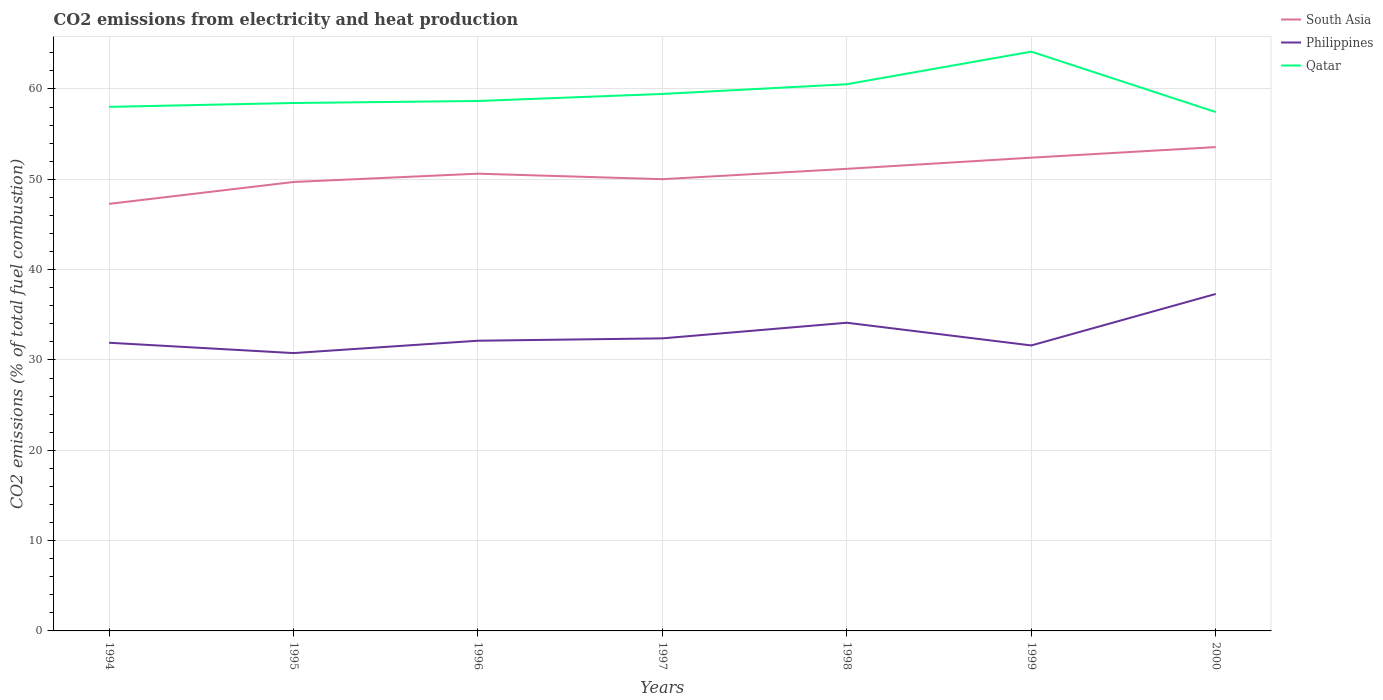Does the line corresponding to Qatar intersect with the line corresponding to South Asia?
Make the answer very short. No. Across all years, what is the maximum amount of CO2 emitted in Philippines?
Your answer should be very brief. 30.76. What is the total amount of CO2 emitted in South Asia in the graph?
Keep it short and to the point. -2.42. What is the difference between the highest and the second highest amount of CO2 emitted in Qatar?
Offer a terse response. 6.69. Is the amount of CO2 emitted in Philippines strictly greater than the amount of CO2 emitted in Qatar over the years?
Give a very brief answer. Yes. How many years are there in the graph?
Your answer should be very brief. 7. Does the graph contain any zero values?
Your response must be concise. No. Does the graph contain grids?
Your answer should be compact. Yes. Where does the legend appear in the graph?
Ensure brevity in your answer.  Top right. How are the legend labels stacked?
Offer a very short reply. Vertical. What is the title of the graph?
Ensure brevity in your answer.  CO2 emissions from electricity and heat production. What is the label or title of the Y-axis?
Give a very brief answer. CO2 emissions (% of total fuel combustion). What is the CO2 emissions (% of total fuel combustion) in South Asia in 1994?
Your answer should be compact. 47.28. What is the CO2 emissions (% of total fuel combustion) in Philippines in 1994?
Your answer should be very brief. 31.9. What is the CO2 emissions (% of total fuel combustion) of Qatar in 1994?
Your answer should be compact. 58.02. What is the CO2 emissions (% of total fuel combustion) of South Asia in 1995?
Provide a short and direct response. 49.7. What is the CO2 emissions (% of total fuel combustion) of Philippines in 1995?
Offer a terse response. 30.76. What is the CO2 emissions (% of total fuel combustion) of Qatar in 1995?
Your answer should be compact. 58.45. What is the CO2 emissions (% of total fuel combustion) of South Asia in 1996?
Provide a succinct answer. 50.62. What is the CO2 emissions (% of total fuel combustion) of Philippines in 1996?
Make the answer very short. 32.13. What is the CO2 emissions (% of total fuel combustion) in Qatar in 1996?
Provide a succinct answer. 58.67. What is the CO2 emissions (% of total fuel combustion) of South Asia in 1997?
Provide a succinct answer. 50.01. What is the CO2 emissions (% of total fuel combustion) in Philippines in 1997?
Keep it short and to the point. 32.39. What is the CO2 emissions (% of total fuel combustion) of Qatar in 1997?
Provide a succinct answer. 59.45. What is the CO2 emissions (% of total fuel combustion) of South Asia in 1998?
Ensure brevity in your answer.  51.16. What is the CO2 emissions (% of total fuel combustion) in Philippines in 1998?
Offer a terse response. 34.12. What is the CO2 emissions (% of total fuel combustion) of Qatar in 1998?
Your answer should be compact. 60.53. What is the CO2 emissions (% of total fuel combustion) in South Asia in 1999?
Give a very brief answer. 52.4. What is the CO2 emissions (% of total fuel combustion) of Philippines in 1999?
Provide a short and direct response. 31.61. What is the CO2 emissions (% of total fuel combustion) of Qatar in 1999?
Your answer should be compact. 64.13. What is the CO2 emissions (% of total fuel combustion) in South Asia in 2000?
Offer a terse response. 53.57. What is the CO2 emissions (% of total fuel combustion) of Philippines in 2000?
Your answer should be compact. 37.31. What is the CO2 emissions (% of total fuel combustion) in Qatar in 2000?
Give a very brief answer. 57.45. Across all years, what is the maximum CO2 emissions (% of total fuel combustion) of South Asia?
Your answer should be very brief. 53.57. Across all years, what is the maximum CO2 emissions (% of total fuel combustion) of Philippines?
Give a very brief answer. 37.31. Across all years, what is the maximum CO2 emissions (% of total fuel combustion) in Qatar?
Your response must be concise. 64.13. Across all years, what is the minimum CO2 emissions (% of total fuel combustion) in South Asia?
Give a very brief answer. 47.28. Across all years, what is the minimum CO2 emissions (% of total fuel combustion) of Philippines?
Keep it short and to the point. 30.76. Across all years, what is the minimum CO2 emissions (% of total fuel combustion) of Qatar?
Your answer should be compact. 57.45. What is the total CO2 emissions (% of total fuel combustion) of South Asia in the graph?
Offer a terse response. 354.74. What is the total CO2 emissions (% of total fuel combustion) of Philippines in the graph?
Your answer should be compact. 230.22. What is the total CO2 emissions (% of total fuel combustion) of Qatar in the graph?
Provide a succinct answer. 416.7. What is the difference between the CO2 emissions (% of total fuel combustion) in South Asia in 1994 and that in 1995?
Give a very brief answer. -2.42. What is the difference between the CO2 emissions (% of total fuel combustion) in Philippines in 1994 and that in 1995?
Offer a very short reply. 1.14. What is the difference between the CO2 emissions (% of total fuel combustion) of Qatar in 1994 and that in 1995?
Offer a terse response. -0.43. What is the difference between the CO2 emissions (% of total fuel combustion) of South Asia in 1994 and that in 1996?
Keep it short and to the point. -3.34. What is the difference between the CO2 emissions (% of total fuel combustion) of Philippines in 1994 and that in 1996?
Give a very brief answer. -0.23. What is the difference between the CO2 emissions (% of total fuel combustion) in Qatar in 1994 and that in 1996?
Your response must be concise. -0.65. What is the difference between the CO2 emissions (% of total fuel combustion) of South Asia in 1994 and that in 1997?
Offer a terse response. -2.73. What is the difference between the CO2 emissions (% of total fuel combustion) in Philippines in 1994 and that in 1997?
Ensure brevity in your answer.  -0.49. What is the difference between the CO2 emissions (% of total fuel combustion) in Qatar in 1994 and that in 1997?
Offer a very short reply. -1.43. What is the difference between the CO2 emissions (% of total fuel combustion) of South Asia in 1994 and that in 1998?
Ensure brevity in your answer.  -3.88. What is the difference between the CO2 emissions (% of total fuel combustion) in Philippines in 1994 and that in 1998?
Offer a terse response. -2.22. What is the difference between the CO2 emissions (% of total fuel combustion) in Qatar in 1994 and that in 1998?
Provide a succinct answer. -2.51. What is the difference between the CO2 emissions (% of total fuel combustion) of South Asia in 1994 and that in 1999?
Ensure brevity in your answer.  -5.11. What is the difference between the CO2 emissions (% of total fuel combustion) of Philippines in 1994 and that in 1999?
Keep it short and to the point. 0.3. What is the difference between the CO2 emissions (% of total fuel combustion) in Qatar in 1994 and that in 1999?
Keep it short and to the point. -6.11. What is the difference between the CO2 emissions (% of total fuel combustion) of South Asia in 1994 and that in 2000?
Provide a succinct answer. -6.29. What is the difference between the CO2 emissions (% of total fuel combustion) in Philippines in 1994 and that in 2000?
Provide a succinct answer. -5.4. What is the difference between the CO2 emissions (% of total fuel combustion) in Qatar in 1994 and that in 2000?
Give a very brief answer. 0.57. What is the difference between the CO2 emissions (% of total fuel combustion) in South Asia in 1995 and that in 1996?
Your answer should be very brief. -0.92. What is the difference between the CO2 emissions (% of total fuel combustion) in Philippines in 1995 and that in 1996?
Provide a succinct answer. -1.37. What is the difference between the CO2 emissions (% of total fuel combustion) of Qatar in 1995 and that in 1996?
Provide a short and direct response. -0.22. What is the difference between the CO2 emissions (% of total fuel combustion) of South Asia in 1995 and that in 1997?
Provide a succinct answer. -0.31. What is the difference between the CO2 emissions (% of total fuel combustion) of Philippines in 1995 and that in 1997?
Your answer should be very brief. -1.63. What is the difference between the CO2 emissions (% of total fuel combustion) in Qatar in 1995 and that in 1997?
Your answer should be very brief. -1. What is the difference between the CO2 emissions (% of total fuel combustion) of South Asia in 1995 and that in 1998?
Provide a succinct answer. -1.46. What is the difference between the CO2 emissions (% of total fuel combustion) in Philippines in 1995 and that in 1998?
Ensure brevity in your answer.  -3.36. What is the difference between the CO2 emissions (% of total fuel combustion) in Qatar in 1995 and that in 1998?
Provide a short and direct response. -2.08. What is the difference between the CO2 emissions (% of total fuel combustion) in South Asia in 1995 and that in 1999?
Keep it short and to the point. -2.69. What is the difference between the CO2 emissions (% of total fuel combustion) of Philippines in 1995 and that in 1999?
Offer a very short reply. -0.84. What is the difference between the CO2 emissions (% of total fuel combustion) of Qatar in 1995 and that in 1999?
Offer a terse response. -5.68. What is the difference between the CO2 emissions (% of total fuel combustion) of South Asia in 1995 and that in 2000?
Your answer should be very brief. -3.86. What is the difference between the CO2 emissions (% of total fuel combustion) in Philippines in 1995 and that in 2000?
Offer a very short reply. -6.55. What is the difference between the CO2 emissions (% of total fuel combustion) of Qatar in 1995 and that in 2000?
Give a very brief answer. 1. What is the difference between the CO2 emissions (% of total fuel combustion) of South Asia in 1996 and that in 1997?
Keep it short and to the point. 0.61. What is the difference between the CO2 emissions (% of total fuel combustion) of Philippines in 1996 and that in 1997?
Your answer should be compact. -0.26. What is the difference between the CO2 emissions (% of total fuel combustion) of Qatar in 1996 and that in 1997?
Offer a very short reply. -0.78. What is the difference between the CO2 emissions (% of total fuel combustion) of South Asia in 1996 and that in 1998?
Offer a very short reply. -0.54. What is the difference between the CO2 emissions (% of total fuel combustion) in Philippines in 1996 and that in 1998?
Make the answer very short. -1.99. What is the difference between the CO2 emissions (% of total fuel combustion) in Qatar in 1996 and that in 1998?
Ensure brevity in your answer.  -1.86. What is the difference between the CO2 emissions (% of total fuel combustion) in South Asia in 1996 and that in 1999?
Give a very brief answer. -1.77. What is the difference between the CO2 emissions (% of total fuel combustion) in Philippines in 1996 and that in 1999?
Offer a very short reply. 0.52. What is the difference between the CO2 emissions (% of total fuel combustion) of Qatar in 1996 and that in 1999?
Offer a terse response. -5.46. What is the difference between the CO2 emissions (% of total fuel combustion) in South Asia in 1996 and that in 2000?
Offer a terse response. -2.94. What is the difference between the CO2 emissions (% of total fuel combustion) in Philippines in 1996 and that in 2000?
Your answer should be compact. -5.18. What is the difference between the CO2 emissions (% of total fuel combustion) in Qatar in 1996 and that in 2000?
Offer a terse response. 1.22. What is the difference between the CO2 emissions (% of total fuel combustion) of South Asia in 1997 and that in 1998?
Keep it short and to the point. -1.15. What is the difference between the CO2 emissions (% of total fuel combustion) in Philippines in 1997 and that in 1998?
Provide a short and direct response. -1.73. What is the difference between the CO2 emissions (% of total fuel combustion) in Qatar in 1997 and that in 1998?
Your answer should be very brief. -1.08. What is the difference between the CO2 emissions (% of total fuel combustion) of South Asia in 1997 and that in 1999?
Your answer should be compact. -2.38. What is the difference between the CO2 emissions (% of total fuel combustion) of Philippines in 1997 and that in 1999?
Offer a terse response. 0.79. What is the difference between the CO2 emissions (% of total fuel combustion) in Qatar in 1997 and that in 1999?
Offer a terse response. -4.68. What is the difference between the CO2 emissions (% of total fuel combustion) in South Asia in 1997 and that in 2000?
Your answer should be very brief. -3.55. What is the difference between the CO2 emissions (% of total fuel combustion) in Philippines in 1997 and that in 2000?
Provide a succinct answer. -4.92. What is the difference between the CO2 emissions (% of total fuel combustion) of Qatar in 1997 and that in 2000?
Your answer should be compact. 2. What is the difference between the CO2 emissions (% of total fuel combustion) of South Asia in 1998 and that in 1999?
Keep it short and to the point. -1.24. What is the difference between the CO2 emissions (% of total fuel combustion) in Philippines in 1998 and that in 1999?
Your answer should be very brief. 2.51. What is the difference between the CO2 emissions (% of total fuel combustion) in Qatar in 1998 and that in 1999?
Keep it short and to the point. -3.61. What is the difference between the CO2 emissions (% of total fuel combustion) of South Asia in 1998 and that in 2000?
Keep it short and to the point. -2.41. What is the difference between the CO2 emissions (% of total fuel combustion) of Philippines in 1998 and that in 2000?
Make the answer very short. -3.19. What is the difference between the CO2 emissions (% of total fuel combustion) of Qatar in 1998 and that in 2000?
Offer a very short reply. 3.08. What is the difference between the CO2 emissions (% of total fuel combustion) in South Asia in 1999 and that in 2000?
Provide a short and direct response. -1.17. What is the difference between the CO2 emissions (% of total fuel combustion) in Philippines in 1999 and that in 2000?
Ensure brevity in your answer.  -5.7. What is the difference between the CO2 emissions (% of total fuel combustion) of Qatar in 1999 and that in 2000?
Provide a succinct answer. 6.69. What is the difference between the CO2 emissions (% of total fuel combustion) in South Asia in 1994 and the CO2 emissions (% of total fuel combustion) in Philippines in 1995?
Your answer should be very brief. 16.52. What is the difference between the CO2 emissions (% of total fuel combustion) in South Asia in 1994 and the CO2 emissions (% of total fuel combustion) in Qatar in 1995?
Your response must be concise. -11.17. What is the difference between the CO2 emissions (% of total fuel combustion) of Philippines in 1994 and the CO2 emissions (% of total fuel combustion) of Qatar in 1995?
Give a very brief answer. -26.54. What is the difference between the CO2 emissions (% of total fuel combustion) in South Asia in 1994 and the CO2 emissions (% of total fuel combustion) in Philippines in 1996?
Offer a terse response. 15.15. What is the difference between the CO2 emissions (% of total fuel combustion) of South Asia in 1994 and the CO2 emissions (% of total fuel combustion) of Qatar in 1996?
Ensure brevity in your answer.  -11.39. What is the difference between the CO2 emissions (% of total fuel combustion) of Philippines in 1994 and the CO2 emissions (% of total fuel combustion) of Qatar in 1996?
Offer a very short reply. -26.77. What is the difference between the CO2 emissions (% of total fuel combustion) in South Asia in 1994 and the CO2 emissions (% of total fuel combustion) in Philippines in 1997?
Offer a terse response. 14.89. What is the difference between the CO2 emissions (% of total fuel combustion) in South Asia in 1994 and the CO2 emissions (% of total fuel combustion) in Qatar in 1997?
Ensure brevity in your answer.  -12.17. What is the difference between the CO2 emissions (% of total fuel combustion) of Philippines in 1994 and the CO2 emissions (% of total fuel combustion) of Qatar in 1997?
Offer a very short reply. -27.55. What is the difference between the CO2 emissions (% of total fuel combustion) in South Asia in 1994 and the CO2 emissions (% of total fuel combustion) in Philippines in 1998?
Make the answer very short. 13.16. What is the difference between the CO2 emissions (% of total fuel combustion) of South Asia in 1994 and the CO2 emissions (% of total fuel combustion) of Qatar in 1998?
Offer a terse response. -13.25. What is the difference between the CO2 emissions (% of total fuel combustion) of Philippines in 1994 and the CO2 emissions (% of total fuel combustion) of Qatar in 1998?
Provide a short and direct response. -28.62. What is the difference between the CO2 emissions (% of total fuel combustion) in South Asia in 1994 and the CO2 emissions (% of total fuel combustion) in Philippines in 1999?
Give a very brief answer. 15.67. What is the difference between the CO2 emissions (% of total fuel combustion) of South Asia in 1994 and the CO2 emissions (% of total fuel combustion) of Qatar in 1999?
Your response must be concise. -16.85. What is the difference between the CO2 emissions (% of total fuel combustion) of Philippines in 1994 and the CO2 emissions (% of total fuel combustion) of Qatar in 1999?
Offer a terse response. -32.23. What is the difference between the CO2 emissions (% of total fuel combustion) in South Asia in 1994 and the CO2 emissions (% of total fuel combustion) in Philippines in 2000?
Provide a short and direct response. 9.97. What is the difference between the CO2 emissions (% of total fuel combustion) of South Asia in 1994 and the CO2 emissions (% of total fuel combustion) of Qatar in 2000?
Offer a terse response. -10.17. What is the difference between the CO2 emissions (% of total fuel combustion) in Philippines in 1994 and the CO2 emissions (% of total fuel combustion) in Qatar in 2000?
Ensure brevity in your answer.  -25.54. What is the difference between the CO2 emissions (% of total fuel combustion) of South Asia in 1995 and the CO2 emissions (% of total fuel combustion) of Philippines in 1996?
Your answer should be compact. 17.57. What is the difference between the CO2 emissions (% of total fuel combustion) in South Asia in 1995 and the CO2 emissions (% of total fuel combustion) in Qatar in 1996?
Offer a very short reply. -8.97. What is the difference between the CO2 emissions (% of total fuel combustion) in Philippines in 1995 and the CO2 emissions (% of total fuel combustion) in Qatar in 1996?
Make the answer very short. -27.91. What is the difference between the CO2 emissions (% of total fuel combustion) in South Asia in 1995 and the CO2 emissions (% of total fuel combustion) in Philippines in 1997?
Offer a terse response. 17.31. What is the difference between the CO2 emissions (% of total fuel combustion) in South Asia in 1995 and the CO2 emissions (% of total fuel combustion) in Qatar in 1997?
Provide a short and direct response. -9.75. What is the difference between the CO2 emissions (% of total fuel combustion) in Philippines in 1995 and the CO2 emissions (% of total fuel combustion) in Qatar in 1997?
Provide a short and direct response. -28.69. What is the difference between the CO2 emissions (% of total fuel combustion) in South Asia in 1995 and the CO2 emissions (% of total fuel combustion) in Philippines in 1998?
Keep it short and to the point. 15.58. What is the difference between the CO2 emissions (% of total fuel combustion) of South Asia in 1995 and the CO2 emissions (% of total fuel combustion) of Qatar in 1998?
Keep it short and to the point. -10.82. What is the difference between the CO2 emissions (% of total fuel combustion) of Philippines in 1995 and the CO2 emissions (% of total fuel combustion) of Qatar in 1998?
Offer a very short reply. -29.77. What is the difference between the CO2 emissions (% of total fuel combustion) of South Asia in 1995 and the CO2 emissions (% of total fuel combustion) of Philippines in 1999?
Your response must be concise. 18.1. What is the difference between the CO2 emissions (% of total fuel combustion) of South Asia in 1995 and the CO2 emissions (% of total fuel combustion) of Qatar in 1999?
Offer a very short reply. -14.43. What is the difference between the CO2 emissions (% of total fuel combustion) of Philippines in 1995 and the CO2 emissions (% of total fuel combustion) of Qatar in 1999?
Offer a terse response. -33.37. What is the difference between the CO2 emissions (% of total fuel combustion) of South Asia in 1995 and the CO2 emissions (% of total fuel combustion) of Philippines in 2000?
Offer a very short reply. 12.4. What is the difference between the CO2 emissions (% of total fuel combustion) of South Asia in 1995 and the CO2 emissions (% of total fuel combustion) of Qatar in 2000?
Keep it short and to the point. -7.74. What is the difference between the CO2 emissions (% of total fuel combustion) in Philippines in 1995 and the CO2 emissions (% of total fuel combustion) in Qatar in 2000?
Give a very brief answer. -26.69. What is the difference between the CO2 emissions (% of total fuel combustion) of South Asia in 1996 and the CO2 emissions (% of total fuel combustion) of Philippines in 1997?
Keep it short and to the point. 18.23. What is the difference between the CO2 emissions (% of total fuel combustion) in South Asia in 1996 and the CO2 emissions (% of total fuel combustion) in Qatar in 1997?
Your answer should be compact. -8.83. What is the difference between the CO2 emissions (% of total fuel combustion) of Philippines in 1996 and the CO2 emissions (% of total fuel combustion) of Qatar in 1997?
Give a very brief answer. -27.32. What is the difference between the CO2 emissions (% of total fuel combustion) of South Asia in 1996 and the CO2 emissions (% of total fuel combustion) of Philippines in 1998?
Make the answer very short. 16.5. What is the difference between the CO2 emissions (% of total fuel combustion) of South Asia in 1996 and the CO2 emissions (% of total fuel combustion) of Qatar in 1998?
Your answer should be very brief. -9.9. What is the difference between the CO2 emissions (% of total fuel combustion) in Philippines in 1996 and the CO2 emissions (% of total fuel combustion) in Qatar in 1998?
Ensure brevity in your answer.  -28.4. What is the difference between the CO2 emissions (% of total fuel combustion) in South Asia in 1996 and the CO2 emissions (% of total fuel combustion) in Philippines in 1999?
Offer a very short reply. 19.02. What is the difference between the CO2 emissions (% of total fuel combustion) of South Asia in 1996 and the CO2 emissions (% of total fuel combustion) of Qatar in 1999?
Offer a very short reply. -13.51. What is the difference between the CO2 emissions (% of total fuel combustion) in Philippines in 1996 and the CO2 emissions (% of total fuel combustion) in Qatar in 1999?
Offer a terse response. -32. What is the difference between the CO2 emissions (% of total fuel combustion) of South Asia in 1996 and the CO2 emissions (% of total fuel combustion) of Philippines in 2000?
Offer a very short reply. 13.32. What is the difference between the CO2 emissions (% of total fuel combustion) in South Asia in 1996 and the CO2 emissions (% of total fuel combustion) in Qatar in 2000?
Provide a short and direct response. -6.82. What is the difference between the CO2 emissions (% of total fuel combustion) in Philippines in 1996 and the CO2 emissions (% of total fuel combustion) in Qatar in 2000?
Your answer should be compact. -25.32. What is the difference between the CO2 emissions (% of total fuel combustion) of South Asia in 1997 and the CO2 emissions (% of total fuel combustion) of Philippines in 1998?
Keep it short and to the point. 15.89. What is the difference between the CO2 emissions (% of total fuel combustion) in South Asia in 1997 and the CO2 emissions (% of total fuel combustion) in Qatar in 1998?
Keep it short and to the point. -10.51. What is the difference between the CO2 emissions (% of total fuel combustion) of Philippines in 1997 and the CO2 emissions (% of total fuel combustion) of Qatar in 1998?
Keep it short and to the point. -28.14. What is the difference between the CO2 emissions (% of total fuel combustion) in South Asia in 1997 and the CO2 emissions (% of total fuel combustion) in Philippines in 1999?
Ensure brevity in your answer.  18.41. What is the difference between the CO2 emissions (% of total fuel combustion) in South Asia in 1997 and the CO2 emissions (% of total fuel combustion) in Qatar in 1999?
Your response must be concise. -14.12. What is the difference between the CO2 emissions (% of total fuel combustion) in Philippines in 1997 and the CO2 emissions (% of total fuel combustion) in Qatar in 1999?
Provide a succinct answer. -31.74. What is the difference between the CO2 emissions (% of total fuel combustion) of South Asia in 1997 and the CO2 emissions (% of total fuel combustion) of Philippines in 2000?
Offer a terse response. 12.71. What is the difference between the CO2 emissions (% of total fuel combustion) of South Asia in 1997 and the CO2 emissions (% of total fuel combustion) of Qatar in 2000?
Your answer should be very brief. -7.43. What is the difference between the CO2 emissions (% of total fuel combustion) of Philippines in 1997 and the CO2 emissions (% of total fuel combustion) of Qatar in 2000?
Your response must be concise. -25.06. What is the difference between the CO2 emissions (% of total fuel combustion) in South Asia in 1998 and the CO2 emissions (% of total fuel combustion) in Philippines in 1999?
Make the answer very short. 19.55. What is the difference between the CO2 emissions (% of total fuel combustion) in South Asia in 1998 and the CO2 emissions (% of total fuel combustion) in Qatar in 1999?
Your answer should be compact. -12.97. What is the difference between the CO2 emissions (% of total fuel combustion) of Philippines in 1998 and the CO2 emissions (% of total fuel combustion) of Qatar in 1999?
Provide a succinct answer. -30.01. What is the difference between the CO2 emissions (% of total fuel combustion) in South Asia in 1998 and the CO2 emissions (% of total fuel combustion) in Philippines in 2000?
Offer a terse response. 13.85. What is the difference between the CO2 emissions (% of total fuel combustion) in South Asia in 1998 and the CO2 emissions (% of total fuel combustion) in Qatar in 2000?
Keep it short and to the point. -6.29. What is the difference between the CO2 emissions (% of total fuel combustion) in Philippines in 1998 and the CO2 emissions (% of total fuel combustion) in Qatar in 2000?
Provide a succinct answer. -23.33. What is the difference between the CO2 emissions (% of total fuel combustion) in South Asia in 1999 and the CO2 emissions (% of total fuel combustion) in Philippines in 2000?
Provide a succinct answer. 15.09. What is the difference between the CO2 emissions (% of total fuel combustion) of South Asia in 1999 and the CO2 emissions (% of total fuel combustion) of Qatar in 2000?
Provide a succinct answer. -5.05. What is the difference between the CO2 emissions (% of total fuel combustion) of Philippines in 1999 and the CO2 emissions (% of total fuel combustion) of Qatar in 2000?
Your response must be concise. -25.84. What is the average CO2 emissions (% of total fuel combustion) in South Asia per year?
Provide a succinct answer. 50.68. What is the average CO2 emissions (% of total fuel combustion) in Philippines per year?
Provide a succinct answer. 32.89. What is the average CO2 emissions (% of total fuel combustion) of Qatar per year?
Make the answer very short. 59.53. In the year 1994, what is the difference between the CO2 emissions (% of total fuel combustion) in South Asia and CO2 emissions (% of total fuel combustion) in Philippines?
Ensure brevity in your answer.  15.38. In the year 1994, what is the difference between the CO2 emissions (% of total fuel combustion) in South Asia and CO2 emissions (% of total fuel combustion) in Qatar?
Give a very brief answer. -10.74. In the year 1994, what is the difference between the CO2 emissions (% of total fuel combustion) of Philippines and CO2 emissions (% of total fuel combustion) of Qatar?
Your answer should be very brief. -26.12. In the year 1995, what is the difference between the CO2 emissions (% of total fuel combustion) in South Asia and CO2 emissions (% of total fuel combustion) in Philippines?
Provide a succinct answer. 18.94. In the year 1995, what is the difference between the CO2 emissions (% of total fuel combustion) of South Asia and CO2 emissions (% of total fuel combustion) of Qatar?
Offer a terse response. -8.75. In the year 1995, what is the difference between the CO2 emissions (% of total fuel combustion) in Philippines and CO2 emissions (% of total fuel combustion) in Qatar?
Offer a terse response. -27.69. In the year 1996, what is the difference between the CO2 emissions (% of total fuel combustion) of South Asia and CO2 emissions (% of total fuel combustion) of Philippines?
Your answer should be very brief. 18.49. In the year 1996, what is the difference between the CO2 emissions (% of total fuel combustion) of South Asia and CO2 emissions (% of total fuel combustion) of Qatar?
Keep it short and to the point. -8.05. In the year 1996, what is the difference between the CO2 emissions (% of total fuel combustion) of Philippines and CO2 emissions (% of total fuel combustion) of Qatar?
Your answer should be compact. -26.54. In the year 1997, what is the difference between the CO2 emissions (% of total fuel combustion) in South Asia and CO2 emissions (% of total fuel combustion) in Philippines?
Keep it short and to the point. 17.62. In the year 1997, what is the difference between the CO2 emissions (% of total fuel combustion) of South Asia and CO2 emissions (% of total fuel combustion) of Qatar?
Provide a short and direct response. -9.44. In the year 1997, what is the difference between the CO2 emissions (% of total fuel combustion) in Philippines and CO2 emissions (% of total fuel combustion) in Qatar?
Make the answer very short. -27.06. In the year 1998, what is the difference between the CO2 emissions (% of total fuel combustion) of South Asia and CO2 emissions (% of total fuel combustion) of Philippines?
Offer a very short reply. 17.04. In the year 1998, what is the difference between the CO2 emissions (% of total fuel combustion) of South Asia and CO2 emissions (% of total fuel combustion) of Qatar?
Provide a short and direct response. -9.37. In the year 1998, what is the difference between the CO2 emissions (% of total fuel combustion) in Philippines and CO2 emissions (% of total fuel combustion) in Qatar?
Keep it short and to the point. -26.41. In the year 1999, what is the difference between the CO2 emissions (% of total fuel combustion) in South Asia and CO2 emissions (% of total fuel combustion) in Philippines?
Give a very brief answer. 20.79. In the year 1999, what is the difference between the CO2 emissions (% of total fuel combustion) of South Asia and CO2 emissions (% of total fuel combustion) of Qatar?
Keep it short and to the point. -11.74. In the year 1999, what is the difference between the CO2 emissions (% of total fuel combustion) of Philippines and CO2 emissions (% of total fuel combustion) of Qatar?
Offer a very short reply. -32.53. In the year 2000, what is the difference between the CO2 emissions (% of total fuel combustion) in South Asia and CO2 emissions (% of total fuel combustion) in Philippines?
Offer a terse response. 16.26. In the year 2000, what is the difference between the CO2 emissions (% of total fuel combustion) in South Asia and CO2 emissions (% of total fuel combustion) in Qatar?
Your answer should be compact. -3.88. In the year 2000, what is the difference between the CO2 emissions (% of total fuel combustion) of Philippines and CO2 emissions (% of total fuel combustion) of Qatar?
Give a very brief answer. -20.14. What is the ratio of the CO2 emissions (% of total fuel combustion) of South Asia in 1994 to that in 1995?
Give a very brief answer. 0.95. What is the ratio of the CO2 emissions (% of total fuel combustion) of Philippines in 1994 to that in 1995?
Offer a very short reply. 1.04. What is the ratio of the CO2 emissions (% of total fuel combustion) of Qatar in 1994 to that in 1995?
Ensure brevity in your answer.  0.99. What is the ratio of the CO2 emissions (% of total fuel combustion) in South Asia in 1994 to that in 1996?
Keep it short and to the point. 0.93. What is the ratio of the CO2 emissions (% of total fuel combustion) of Qatar in 1994 to that in 1996?
Make the answer very short. 0.99. What is the ratio of the CO2 emissions (% of total fuel combustion) of South Asia in 1994 to that in 1997?
Your answer should be very brief. 0.95. What is the ratio of the CO2 emissions (% of total fuel combustion) in South Asia in 1994 to that in 1998?
Your answer should be compact. 0.92. What is the ratio of the CO2 emissions (% of total fuel combustion) in Philippines in 1994 to that in 1998?
Provide a succinct answer. 0.94. What is the ratio of the CO2 emissions (% of total fuel combustion) in Qatar in 1994 to that in 1998?
Your answer should be very brief. 0.96. What is the ratio of the CO2 emissions (% of total fuel combustion) of South Asia in 1994 to that in 1999?
Give a very brief answer. 0.9. What is the ratio of the CO2 emissions (% of total fuel combustion) in Philippines in 1994 to that in 1999?
Your answer should be very brief. 1.01. What is the ratio of the CO2 emissions (% of total fuel combustion) of Qatar in 1994 to that in 1999?
Make the answer very short. 0.9. What is the ratio of the CO2 emissions (% of total fuel combustion) in South Asia in 1994 to that in 2000?
Make the answer very short. 0.88. What is the ratio of the CO2 emissions (% of total fuel combustion) of Philippines in 1994 to that in 2000?
Provide a short and direct response. 0.86. What is the ratio of the CO2 emissions (% of total fuel combustion) in Qatar in 1994 to that in 2000?
Give a very brief answer. 1.01. What is the ratio of the CO2 emissions (% of total fuel combustion) in South Asia in 1995 to that in 1996?
Offer a terse response. 0.98. What is the ratio of the CO2 emissions (% of total fuel combustion) in Philippines in 1995 to that in 1996?
Your answer should be compact. 0.96. What is the ratio of the CO2 emissions (% of total fuel combustion) of South Asia in 1995 to that in 1997?
Give a very brief answer. 0.99. What is the ratio of the CO2 emissions (% of total fuel combustion) of Philippines in 1995 to that in 1997?
Provide a succinct answer. 0.95. What is the ratio of the CO2 emissions (% of total fuel combustion) in Qatar in 1995 to that in 1997?
Provide a succinct answer. 0.98. What is the ratio of the CO2 emissions (% of total fuel combustion) in South Asia in 1995 to that in 1998?
Your response must be concise. 0.97. What is the ratio of the CO2 emissions (% of total fuel combustion) of Philippines in 1995 to that in 1998?
Your response must be concise. 0.9. What is the ratio of the CO2 emissions (% of total fuel combustion) in Qatar in 1995 to that in 1998?
Give a very brief answer. 0.97. What is the ratio of the CO2 emissions (% of total fuel combustion) in South Asia in 1995 to that in 1999?
Make the answer very short. 0.95. What is the ratio of the CO2 emissions (% of total fuel combustion) in Philippines in 1995 to that in 1999?
Offer a very short reply. 0.97. What is the ratio of the CO2 emissions (% of total fuel combustion) in Qatar in 1995 to that in 1999?
Your response must be concise. 0.91. What is the ratio of the CO2 emissions (% of total fuel combustion) of South Asia in 1995 to that in 2000?
Provide a succinct answer. 0.93. What is the ratio of the CO2 emissions (% of total fuel combustion) of Philippines in 1995 to that in 2000?
Your answer should be very brief. 0.82. What is the ratio of the CO2 emissions (% of total fuel combustion) of Qatar in 1995 to that in 2000?
Your answer should be very brief. 1.02. What is the ratio of the CO2 emissions (% of total fuel combustion) in South Asia in 1996 to that in 1997?
Make the answer very short. 1.01. What is the ratio of the CO2 emissions (% of total fuel combustion) in Philippines in 1996 to that in 1997?
Your response must be concise. 0.99. What is the ratio of the CO2 emissions (% of total fuel combustion) of Qatar in 1996 to that in 1997?
Provide a succinct answer. 0.99. What is the ratio of the CO2 emissions (% of total fuel combustion) in South Asia in 1996 to that in 1998?
Ensure brevity in your answer.  0.99. What is the ratio of the CO2 emissions (% of total fuel combustion) of Philippines in 1996 to that in 1998?
Your response must be concise. 0.94. What is the ratio of the CO2 emissions (% of total fuel combustion) in Qatar in 1996 to that in 1998?
Give a very brief answer. 0.97. What is the ratio of the CO2 emissions (% of total fuel combustion) in South Asia in 1996 to that in 1999?
Provide a short and direct response. 0.97. What is the ratio of the CO2 emissions (% of total fuel combustion) of Philippines in 1996 to that in 1999?
Offer a very short reply. 1.02. What is the ratio of the CO2 emissions (% of total fuel combustion) of Qatar in 1996 to that in 1999?
Make the answer very short. 0.91. What is the ratio of the CO2 emissions (% of total fuel combustion) in South Asia in 1996 to that in 2000?
Provide a succinct answer. 0.95. What is the ratio of the CO2 emissions (% of total fuel combustion) of Philippines in 1996 to that in 2000?
Your answer should be very brief. 0.86. What is the ratio of the CO2 emissions (% of total fuel combustion) in Qatar in 1996 to that in 2000?
Give a very brief answer. 1.02. What is the ratio of the CO2 emissions (% of total fuel combustion) in South Asia in 1997 to that in 1998?
Give a very brief answer. 0.98. What is the ratio of the CO2 emissions (% of total fuel combustion) of Philippines in 1997 to that in 1998?
Your answer should be compact. 0.95. What is the ratio of the CO2 emissions (% of total fuel combustion) of Qatar in 1997 to that in 1998?
Offer a very short reply. 0.98. What is the ratio of the CO2 emissions (% of total fuel combustion) in South Asia in 1997 to that in 1999?
Your answer should be very brief. 0.95. What is the ratio of the CO2 emissions (% of total fuel combustion) in Philippines in 1997 to that in 1999?
Offer a terse response. 1.02. What is the ratio of the CO2 emissions (% of total fuel combustion) in Qatar in 1997 to that in 1999?
Keep it short and to the point. 0.93. What is the ratio of the CO2 emissions (% of total fuel combustion) in South Asia in 1997 to that in 2000?
Your answer should be compact. 0.93. What is the ratio of the CO2 emissions (% of total fuel combustion) of Philippines in 1997 to that in 2000?
Offer a terse response. 0.87. What is the ratio of the CO2 emissions (% of total fuel combustion) of Qatar in 1997 to that in 2000?
Your response must be concise. 1.03. What is the ratio of the CO2 emissions (% of total fuel combustion) in South Asia in 1998 to that in 1999?
Offer a very short reply. 0.98. What is the ratio of the CO2 emissions (% of total fuel combustion) in Philippines in 1998 to that in 1999?
Your answer should be very brief. 1.08. What is the ratio of the CO2 emissions (% of total fuel combustion) in Qatar in 1998 to that in 1999?
Your answer should be compact. 0.94. What is the ratio of the CO2 emissions (% of total fuel combustion) in South Asia in 1998 to that in 2000?
Offer a terse response. 0.96. What is the ratio of the CO2 emissions (% of total fuel combustion) in Philippines in 1998 to that in 2000?
Your answer should be compact. 0.91. What is the ratio of the CO2 emissions (% of total fuel combustion) of Qatar in 1998 to that in 2000?
Your answer should be very brief. 1.05. What is the ratio of the CO2 emissions (% of total fuel combustion) of South Asia in 1999 to that in 2000?
Provide a succinct answer. 0.98. What is the ratio of the CO2 emissions (% of total fuel combustion) in Philippines in 1999 to that in 2000?
Provide a succinct answer. 0.85. What is the ratio of the CO2 emissions (% of total fuel combustion) of Qatar in 1999 to that in 2000?
Your answer should be compact. 1.12. What is the difference between the highest and the second highest CO2 emissions (% of total fuel combustion) of South Asia?
Your answer should be compact. 1.17. What is the difference between the highest and the second highest CO2 emissions (% of total fuel combustion) in Philippines?
Provide a succinct answer. 3.19. What is the difference between the highest and the second highest CO2 emissions (% of total fuel combustion) of Qatar?
Provide a short and direct response. 3.61. What is the difference between the highest and the lowest CO2 emissions (% of total fuel combustion) of South Asia?
Your answer should be very brief. 6.29. What is the difference between the highest and the lowest CO2 emissions (% of total fuel combustion) in Philippines?
Make the answer very short. 6.55. What is the difference between the highest and the lowest CO2 emissions (% of total fuel combustion) in Qatar?
Offer a very short reply. 6.69. 